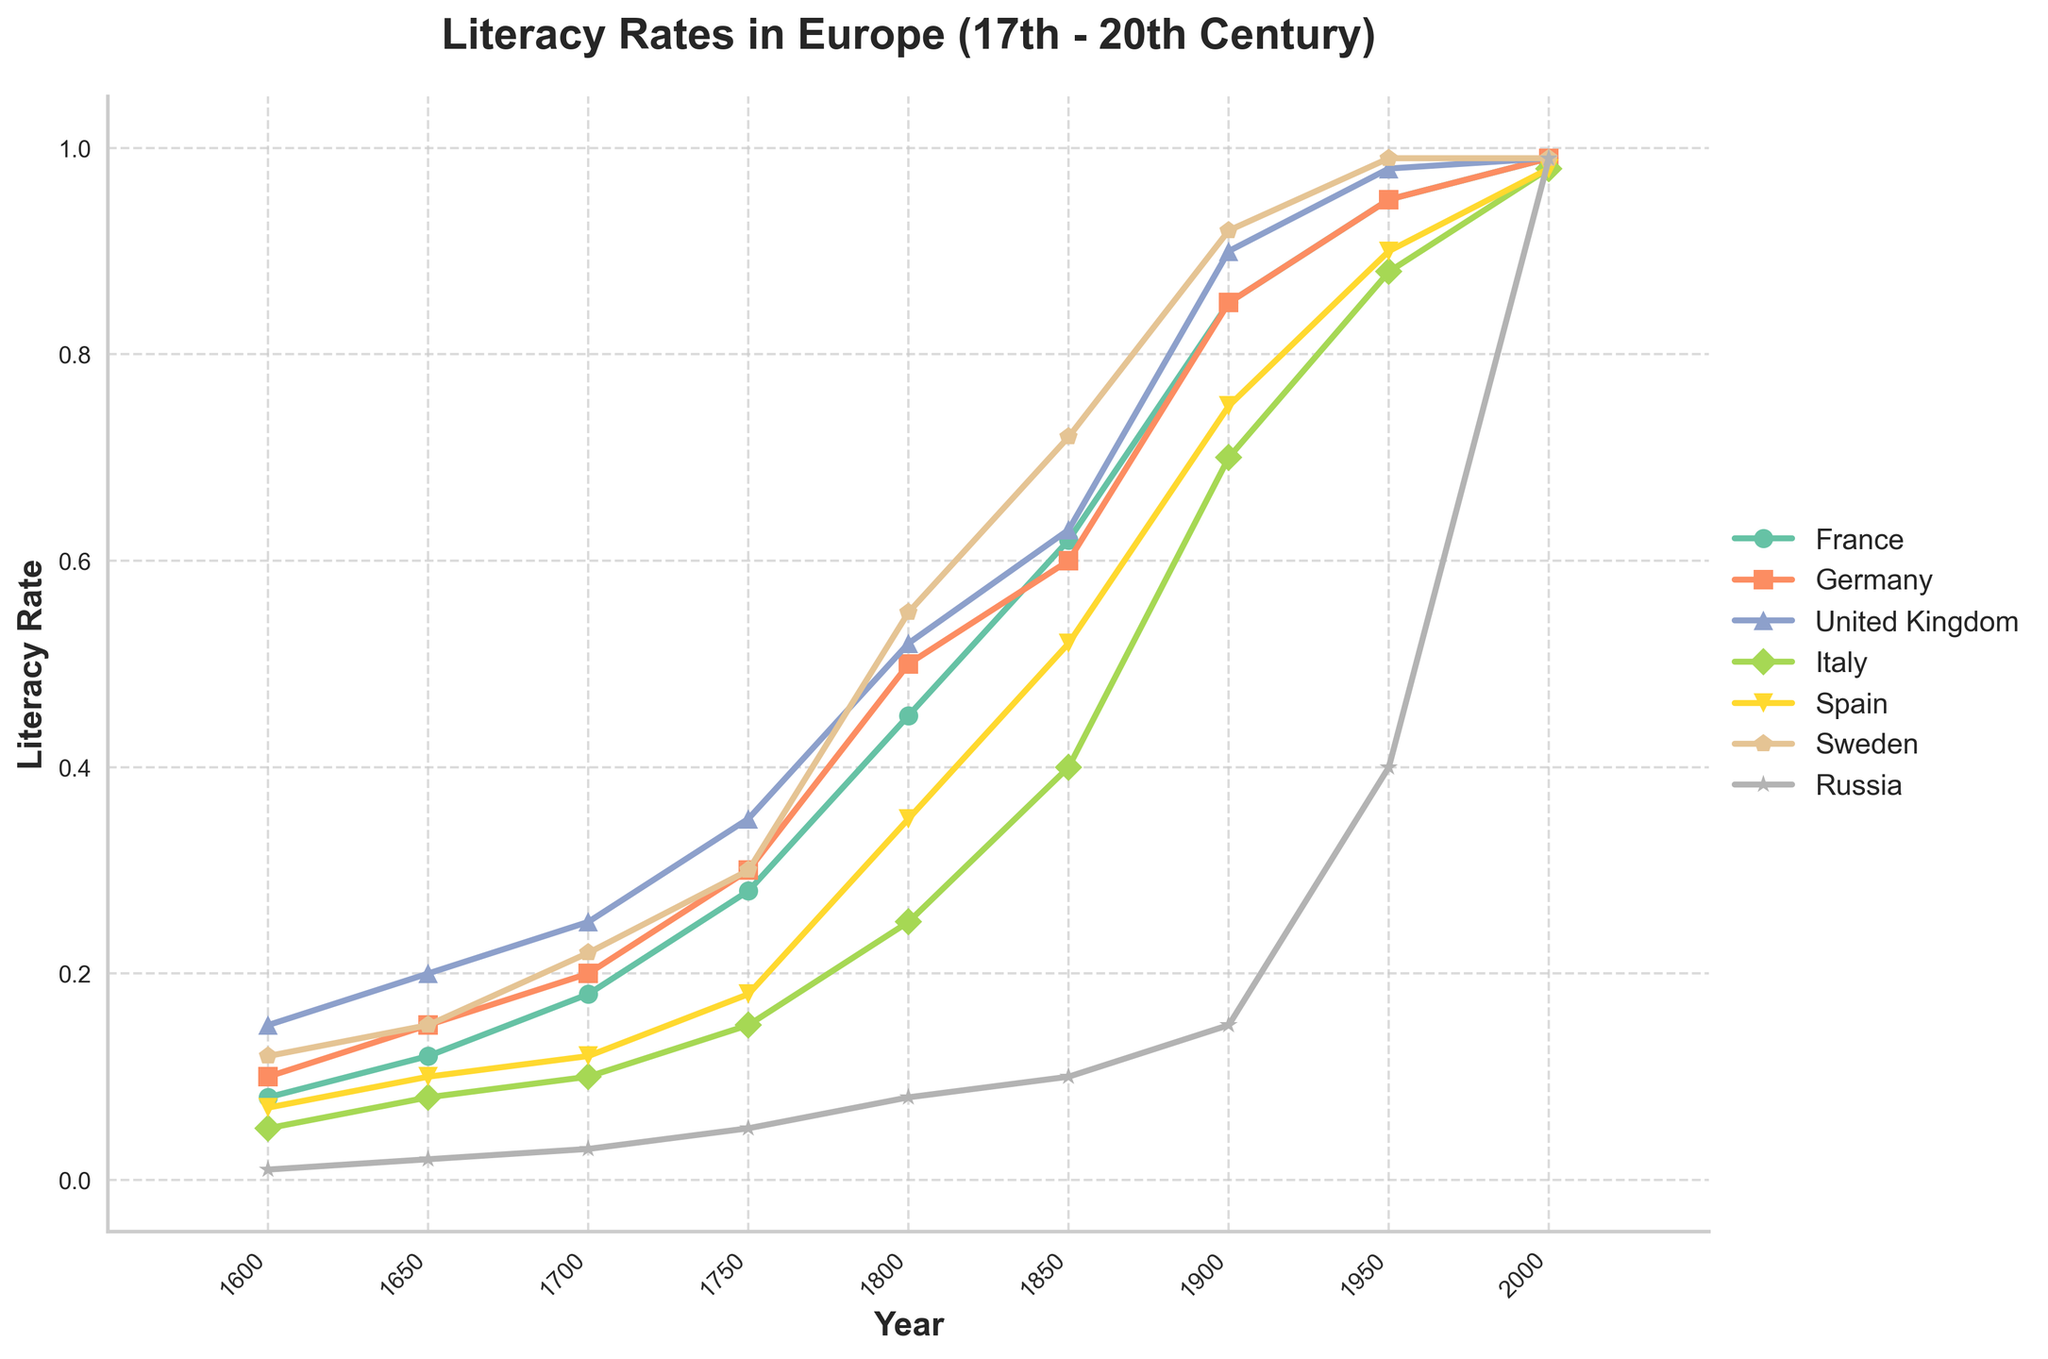Which country had the highest literacy rate in 1950? Look at the 1950 data point for each country. The United Kingdom has the highest rate at 0.98.
Answer: United Kingdom How did the literacy rate in France change from 1600 to 1900? Note the literacy rate in France at 1600 (0.08) and 1900 (0.85). Calculate the increase: 0.85 - 0.08 = 0.77.
Answer: Increased by 0.77 What's the difference in literacy rate between Germany and Russia in 1800? Look at the 1800 data points for Germany (0.5) and Russia (0.08). Calculate the difference: 0.5 - 0.08 = 0.42.
Answer: 0.42 Which country had the most significant increase in literacy rate from 1700 to 1800? Calculate the increase for each country between 1700 and 1800 and compare them. France: 0.45 - 0.18 = 0.27, Germany: 0.5 - 0.2 = 0.3, United Kingdom: 0.52 - 0.25 = 0.27, Italy: 0.25 - 0.1 = 0.15, Spain: 0.35 - 0.12 = 0.23, Sweden: 0.55 - 0.22 = 0.33, Russia: 0.08 - 0.03 = 0.05. Sweden had the most significant increase.
Answer: Sweden By how much did Spain's literacy rate improve from 1800 to 1950? Determine the change from 1800 (0.35) to 1950 (0.9). Calculate the improvement: 0.9 - 0.35 = 0.55.
Answer: Improved by 0.55 Which countries reached a 99% literacy rate by the year 2000? Observe the 2000 data points and find which countries have a literacy rate of 0.99: France, Germany, United Kingdom, Sweden, Russia.
Answer: France, Germany, United Kingdom, Sweden, Russia Did any country have a decreasing literacy rate at any point from 1600 to 2000? Examine the trends for each country; all countries show increasing literacy rates over time.
Answer: No Between which consecutive periods did Italy's literacy rate increase the most? Calculate the differences between consecutive periods for Italy: 1600-1650: 0.08-0.05=0.03, 1650-1700: 0.1-0.08=0.02, 1700-1750: 0.15-0.1=0.05, 1750-1800: 0.25-0.15=0.1, 1800-1850: 0.4-0.25=0.15, 1850-1900: 0.7-0.4=0.3, 1900-1950: 0.88-0.7=0.18, 1950-2000: 0.98-0.88=0.1. The maximum increase is from 1850 to 1900.
Answer: 1850 to 1900 What was the average literacy rate in Sweden over the entire period? Sum the literacy rates for Sweden and divide by the number of periods: (0.12+0.15+0.22+0.3+0.55+0.72+0.92+0.99+0.99)/9. Calculate: 4.96/9 = 0.55.
Answer: 0.55 